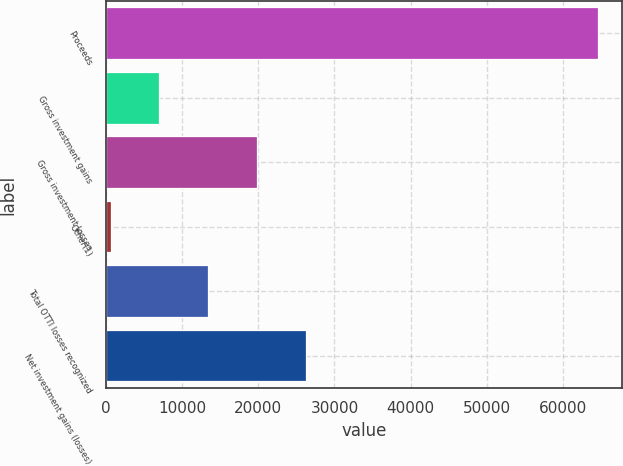Convert chart. <chart><loc_0><loc_0><loc_500><loc_500><bar_chart><fcel>Proceeds<fcel>Gross investment gains<fcel>Gross investment losses<fcel>Other(1)<fcel>Total OTTI losses recognized<fcel>Net investment gains (losses)<nl><fcel>64602<fcel>6989.4<fcel>19792.2<fcel>588<fcel>13390.8<fcel>26193.6<nl></chart> 